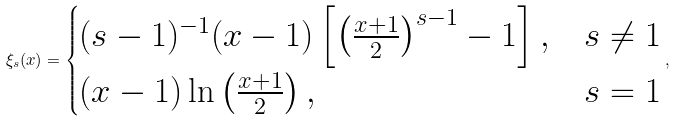<formula> <loc_0><loc_0><loc_500><loc_500>\xi _ { s } ( x ) = \begin{cases} { ( s - 1 ) ^ { - 1 } ( x - 1 ) \left [ { \left ( { \frac { x + 1 } { 2 } } \right ) ^ { s - 1 } - 1 } \right ] , } & { s \ne 1 } \\ { ( x - 1 ) \ln \left ( { \frac { x + 1 } { 2 } } \right ) , } & { s = 1 } \\ \end{cases} ,</formula> 